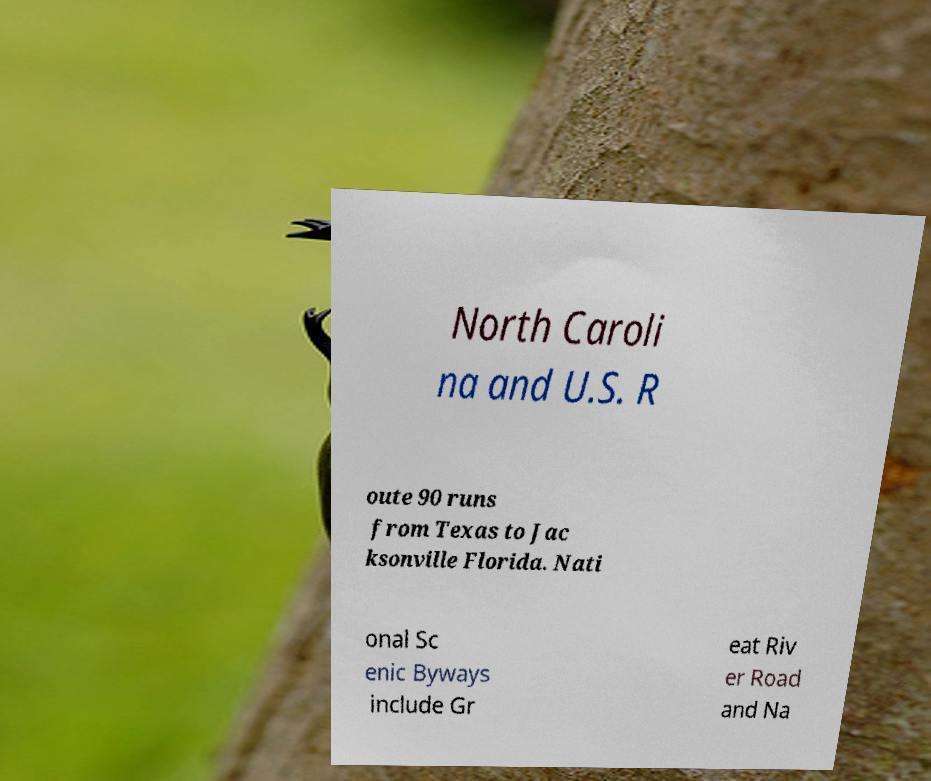Can you read and provide the text displayed in the image?This photo seems to have some interesting text. Can you extract and type it out for me? North Caroli na and U.S. R oute 90 runs from Texas to Jac ksonville Florida. Nati onal Sc enic Byways include Gr eat Riv er Road and Na 